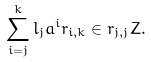<formula> <loc_0><loc_0><loc_500><loc_500>\sum _ { i = j } ^ { k } l _ { j } a ^ { i } r _ { i , k } \in r _ { j , j } Z .</formula> 